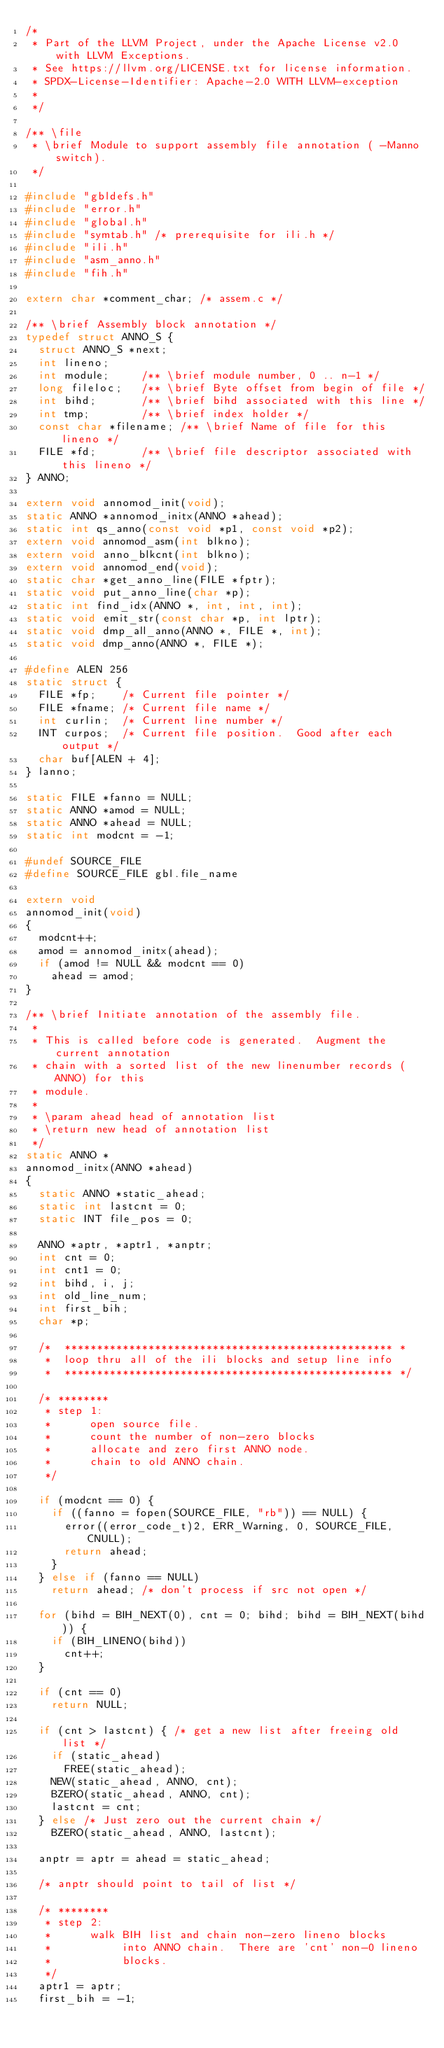<code> <loc_0><loc_0><loc_500><loc_500><_C++_>/*
 * Part of the LLVM Project, under the Apache License v2.0 with LLVM Exceptions.
 * See https://llvm.org/LICENSE.txt for license information.
 * SPDX-License-Identifier: Apache-2.0 WITH LLVM-exception
 *
 */

/** \file
 * \brief Module to support assembly file annotation ( -Manno switch).
 */

#include "gbldefs.h"
#include "error.h"
#include "global.h"
#include "symtab.h" /* prerequisite for ili.h */
#include "ili.h"
#include "asm_anno.h"
#include "fih.h"

extern char *comment_char; /* assem.c */

/** \brief Assembly block annotation */
typedef struct ANNO_S {
  struct ANNO_S *next;
  int lineno;
  int module;     /** \brief module number, 0 .. n-1 */
  long fileloc;   /** \brief Byte offset from begin of file */
  int bihd;       /** \brief bihd associated with this line */
  int tmp;        /** \brief index holder */
  const char *filename; /** \brief Name of file for this lineno */
  FILE *fd;       /** \brief file descriptor associated with this lineno */
} ANNO;

extern void annomod_init(void);
static ANNO *annomod_initx(ANNO *ahead);
static int qs_anno(const void *p1, const void *p2);
extern void annomod_asm(int blkno);
extern void anno_blkcnt(int blkno);
extern void annomod_end(void);
static char *get_anno_line(FILE *fptr);
static void put_anno_line(char *p);
static int find_idx(ANNO *, int, int, int);
static void emit_str(const char *p, int lptr);
static void dmp_all_anno(ANNO *, FILE *, int);
static void dmp_anno(ANNO *, FILE *);

#define ALEN 256
static struct {
  FILE *fp;    /* Current file pointer */
  FILE *fname; /* Current file name */
  int curlin;  /* Current line number */
  INT curpos;  /* Current file position.  Good after each output */
  char buf[ALEN + 4];
} lanno;

static FILE *fanno = NULL;
static ANNO *amod = NULL;
static ANNO *ahead = NULL;
static int modcnt = -1;

#undef SOURCE_FILE
#define SOURCE_FILE gbl.file_name

extern void
annomod_init(void)
{
  modcnt++;
  amod = annomod_initx(ahead);
  if (amod != NULL && modcnt == 0)
    ahead = amod;
}

/** \brief Initiate annotation of the assembly file.
 *
 * This is called before code is generated.  Augment the current annotation
 * chain with a sorted list of the new linenumber records (ANNO) for this
 * module.
 *
 * \param ahead head of annotation list
 * \return new head of annotation list
 */
static ANNO *
annomod_initx(ANNO *ahead)
{
  static ANNO *static_ahead;
  static int lastcnt = 0;
  static INT file_pos = 0;

  ANNO *aptr, *aptr1, *anptr;
  int cnt = 0;
  int cnt1 = 0;
  int bihd, i, j;
  int old_line_num;
  int first_bih;
  char *p;

  /*  *************************************************** *
   *  loop thru all of the ili blocks and setup line info
   *  *************************************************** */

  /* ********
   * step 1:
   *      open source file.
   *      count the number of non-zero blocks
   *      allocate and zero first ANNO node.
   *      chain to old ANNO chain.
   */

  if (modcnt == 0) {
    if ((fanno = fopen(SOURCE_FILE, "rb")) == NULL) {
      error((error_code_t)2, ERR_Warning, 0, SOURCE_FILE, CNULL);
      return ahead;
    }
  } else if (fanno == NULL)
    return ahead; /* don't process if src not open */

  for (bihd = BIH_NEXT(0), cnt = 0; bihd; bihd = BIH_NEXT(bihd)) {
    if (BIH_LINENO(bihd))
      cnt++;
  }

  if (cnt == 0)
    return NULL;

  if (cnt > lastcnt) { /* get a new list after freeing old list */
    if (static_ahead)
      FREE(static_ahead);
    NEW(static_ahead, ANNO, cnt);
    BZERO(static_ahead, ANNO, cnt);
    lastcnt = cnt;
  } else /* Just zero out the current chain */
    BZERO(static_ahead, ANNO, lastcnt);

  anptr = aptr = ahead = static_ahead;

  /* anptr should point to tail of list */

  /* ********
   * step 2:
   *      walk BIH list and chain non-zero lineno blocks
   *           into ANNO chain.  There are 'cnt' non-0 lineno
   *           blocks.
   */
  aptr1 = aptr;
  first_bih = -1;
</code> 